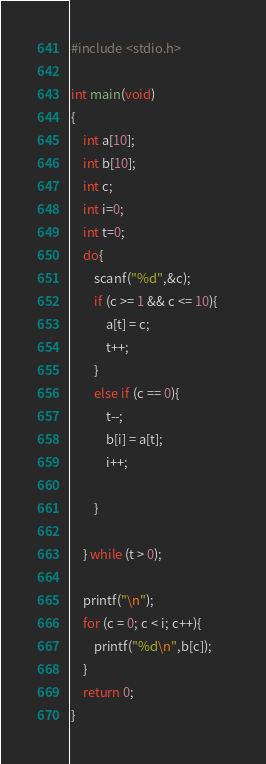Convert code to text. <code><loc_0><loc_0><loc_500><loc_500><_C_>#include <stdio.h>

int main(void)
{
	int a[10];
	int b[10];
	int c;
	int i=0;
	int t=0;	
	do{
		scanf("%d",&c);
		if (c >= 1 && c <= 10){	
			a[t] = c;			
			t++;				
		}
		else if (c == 0){		
			t--;		
			b[i] = a[t];	
			i++;
			
		}

	} while (t > 0);	

	printf("\n");
	for (c = 0; c < i; c++){	
		printf("%d\n",b[c]);
	}
	return 0;
}</code> 